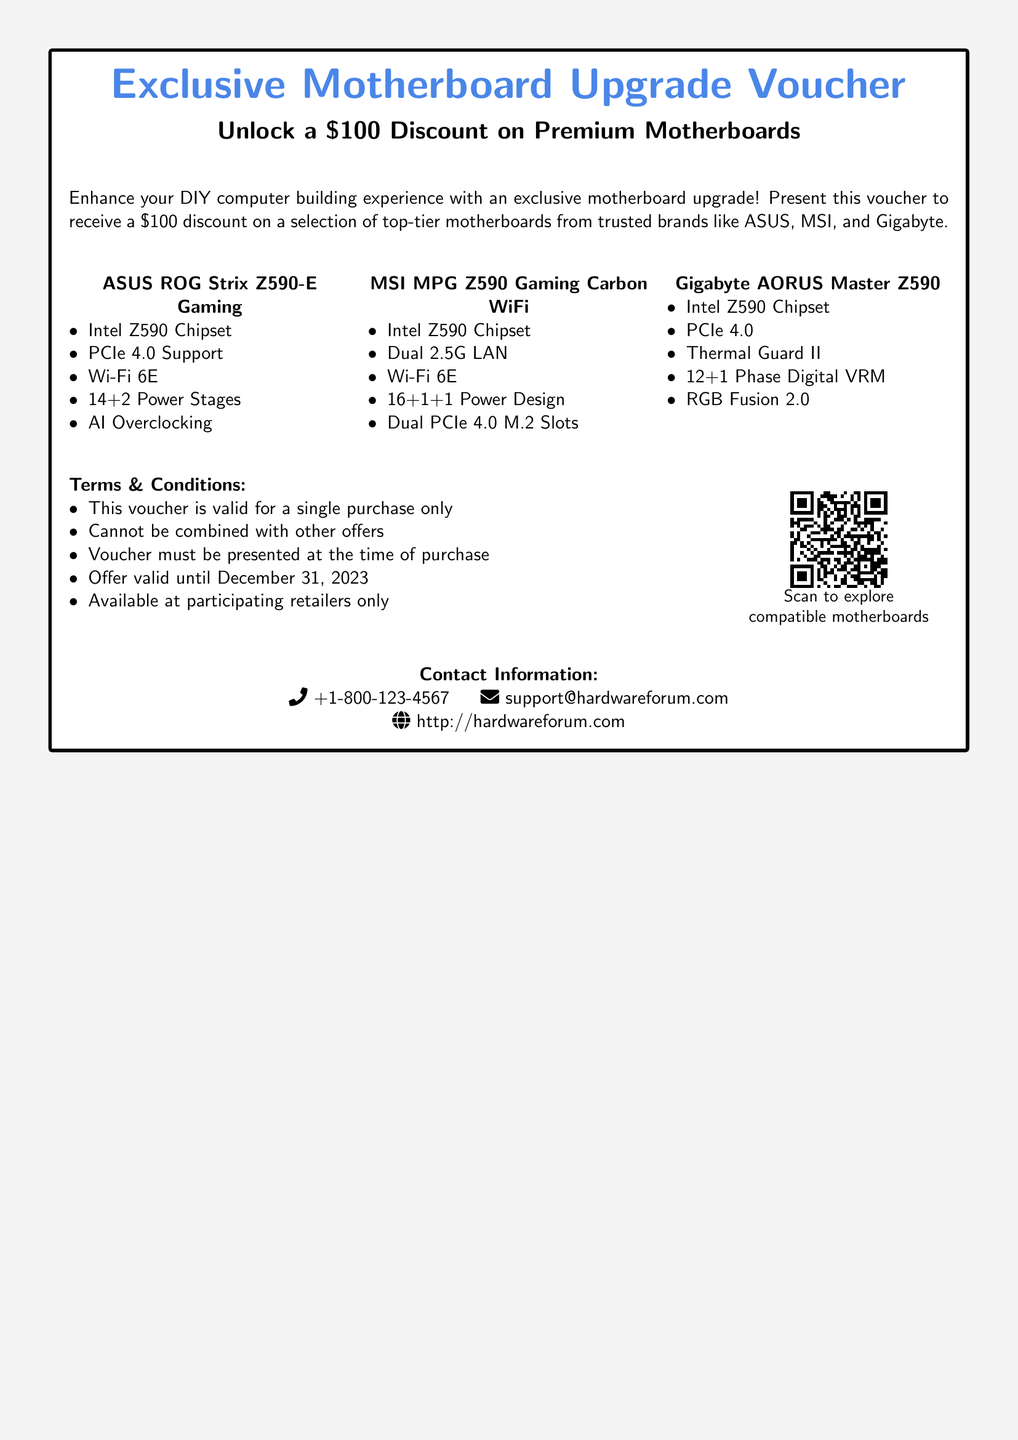What is the discount amount offered by the voucher? The document explicitly states that the voucher provides a discount of $100 on selected motherboards.
Answer: $100 What are the participating brands for the motherboards? The voucher lists ASUS, MSI, and Gigabyte as the trusted brands for the motherboards eligible for the discount.
Answer: ASUS, MSI, Gigabyte What is the validity date of the voucher? The voucher specifies that the offer is valid until December 31, 2023.
Answer: December 31, 2023 Which motherboard features AI Overclocking? The ASUS ROG Strix Z590-E Gaming motherboard is mentioned as having AI Overclocking in its specifications.
Answer: ASUS ROG Strix Z590-E Gaming What is the QR code intended to provide? The QR code in the document leads to a selection of compatible motherboards when scanned, as stated in the text.
Answer: Compatible motherboards How many power stages does the MSI MPG Z590 Gaming Carbon WiFi have? The specifications of the MSI MPG Z590 Gaming Carbon WiFi indicate that it has a 16+1+1 power design.
Answer: 16+1+1 What is a condition regarding the voucher's use? One of the conditions states that the voucher cannot be combined with other offers when making a purchase.
Answer: Cannot be combined with other offers What type of document is this? The document is a gift voucher specifically designed for an exclusive motherboard upgrade and discount offer.
Answer: Gift voucher 